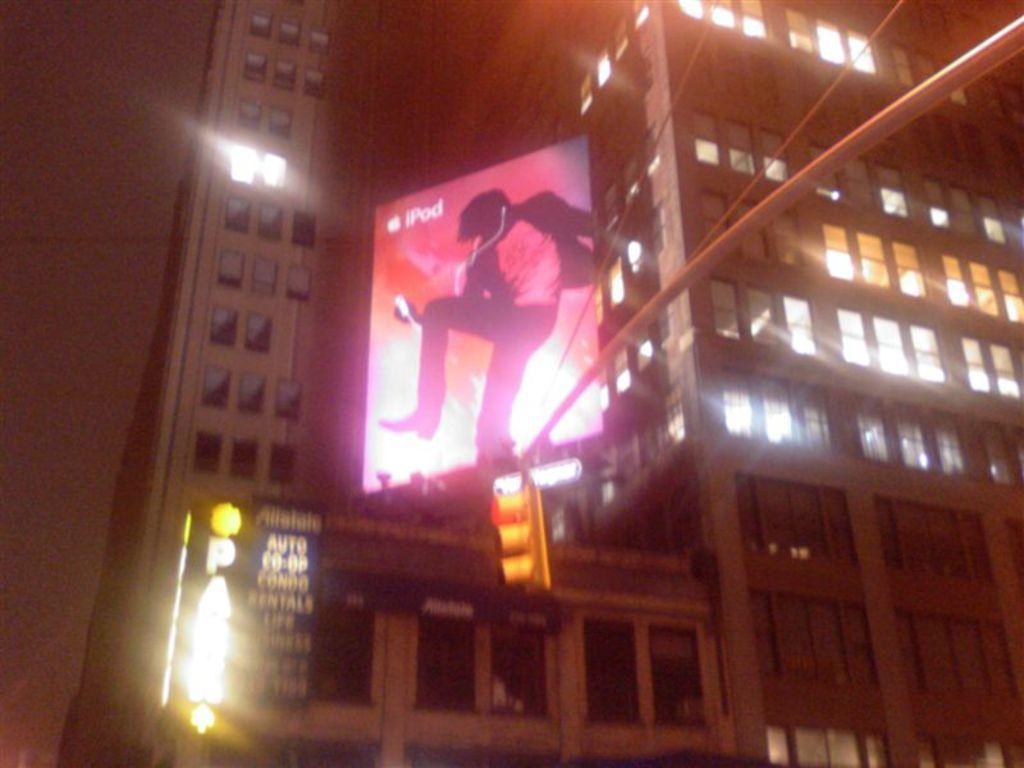What structures can be seen in the image? There are buildings in the image. Is there anything special on top of one of the buildings? Yes, there is a banner on top of a building. What can be seen near the buildings that helps regulate traffic? There is a traffic light signal in the image. What type of plastic is used to make the protest cushions in the image? There is no protest or cushions present in the image, so it is not possible to determine the type of plastic used. 